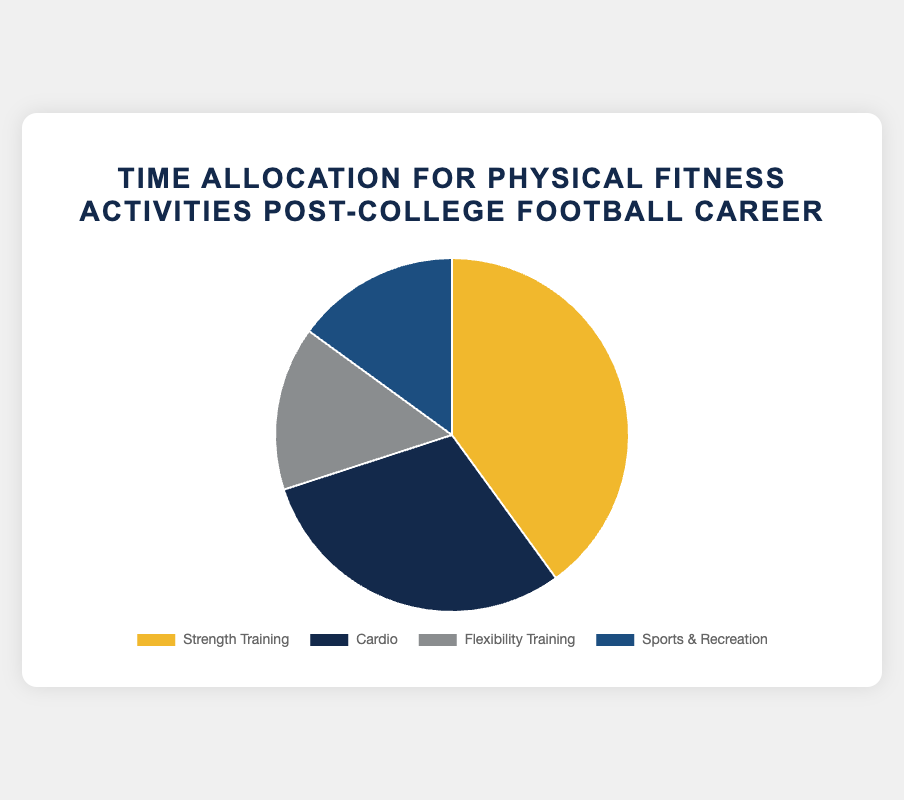What is the largest category shown in the pie chart? The largest category is represented by the biggest slice of the pie chart. It is labeled "Strength Training" and takes up 40% of the chart.
Answer: Strength Training Which category has equal portions in the pie chart? The pie chart shows that "Flexibility Training" and "Sports & Recreation" both take up 15% of the chart each, making them equal in size.
Answer: Flexibility Training and Sports & Recreation How much more percentage is allocated to Cardio than to Sports & Recreation? To find how much more percentage is allocated to Cardio than to Sports & Recreation, subtract the percentage of Sports & Recreation (15%) from the percentage of Cardio (30%): 30% - 15% = 15%.
Answer: 15% What percentage of activities are not related to strength training? To find the percentage of activities not related to strength training, add the percentages of the other categories. That is, Cardio (30%) + Flexibility Training (15%) + Sports & Recreation (15%) = 60%.
Answer: 60% If you combine Flexibility Training and Sports & Recreation, what portion of the pie chart do they represent together? Adding the percentages of Flexibility Training (15%) and Sports & Recreation (15%): 15% + 15% = 30%.
Answer: 30% Among the activities listed for each category, which ones are part of Strength Training? The activities listed for Strength Training in the data are Weightlifting, Resistance Training, and Bodyweight Exercises.
Answer: Weightlifting, Resistance Training, Bodyweight Exercises What is the difference between the largest and smallest categories in terms of percentage? The largest category is Strength Training (40%) and the smallest categories are Flexibility Training and Sports & Recreation (both 15%). The difference is calculated as 40% - 15% = 25%.
Answer: 25% Which category is represented by the blue slice of the pie chart? Observing the colors of the slices, the blue slice corresponds to the second category listed, which is Cardio (30%).
Answer: Cardio 